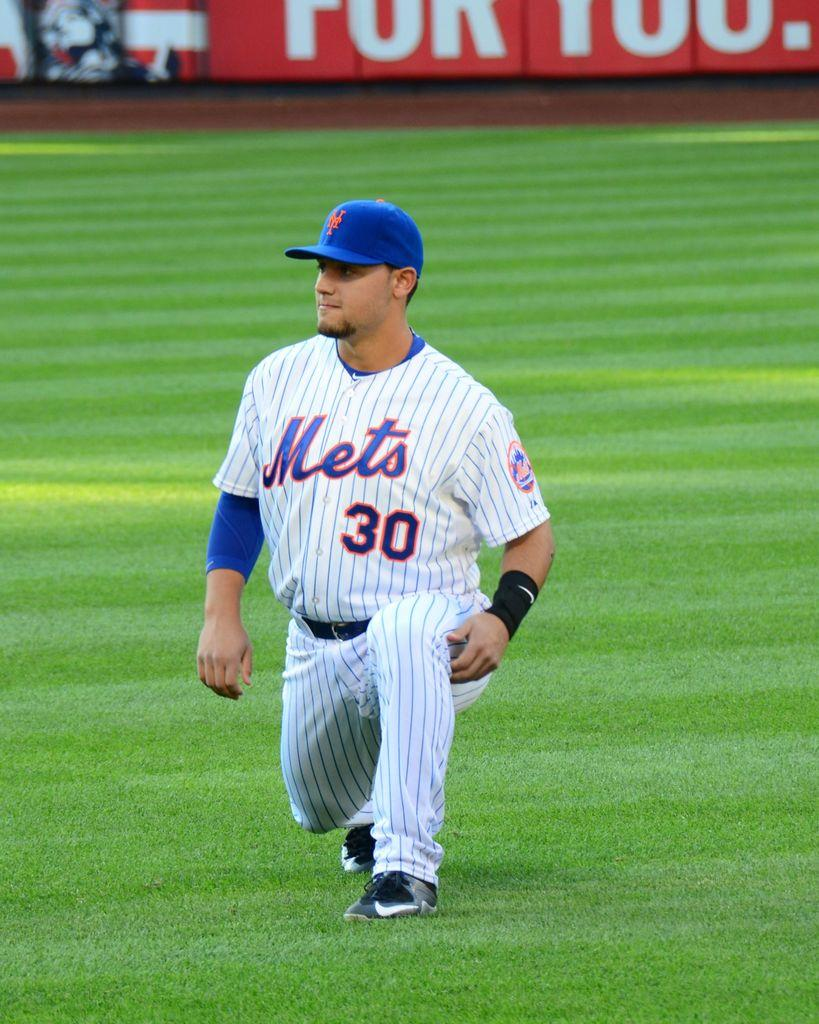<image>
Give a short and clear explanation of the subsequent image. A Mets baseball player number 30 stretches his hamstring. 